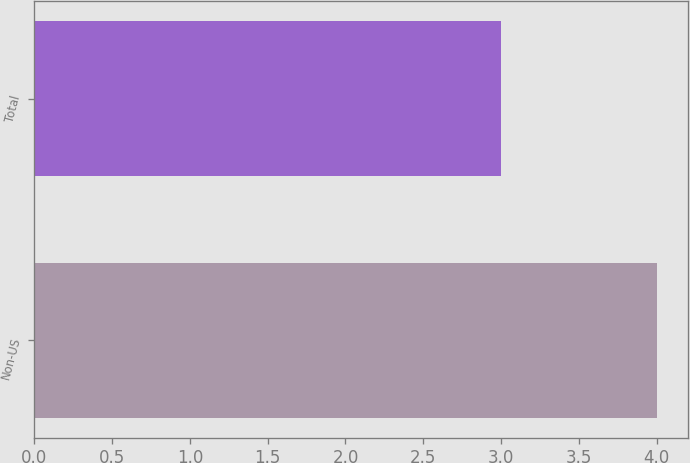<chart> <loc_0><loc_0><loc_500><loc_500><bar_chart><fcel>Non-US<fcel>Total<nl><fcel>4<fcel>3<nl></chart> 